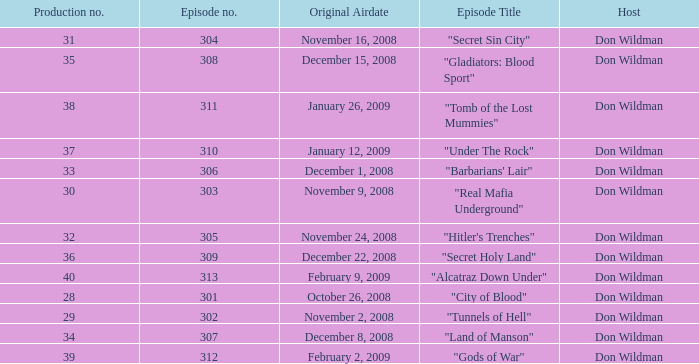What is the episode number of the episode that originally aired on January 26, 2009 and had a production number smaller than 38? 0.0. Would you be able to parse every entry in this table? {'header': ['Production no.', 'Episode no.', 'Original Airdate', 'Episode Title', 'Host'], 'rows': [['31', '304', 'November 16, 2008', '"Secret Sin City"', 'Don Wildman'], ['35', '308', 'December 15, 2008', '"Gladiators: Blood Sport"', 'Don Wildman'], ['38', '311', 'January 26, 2009', '"Tomb of the Lost Mummies"', 'Don Wildman'], ['37', '310', 'January 12, 2009', '"Under The Rock"', 'Don Wildman'], ['33', '306', 'December 1, 2008', '"Barbarians\' Lair"', 'Don Wildman'], ['30', '303', 'November 9, 2008', '"Real Mafia Underground"', 'Don Wildman'], ['32', '305', 'November 24, 2008', '"Hitler\'s Trenches"', 'Don Wildman'], ['36', '309', 'December 22, 2008', '"Secret Holy Land"', 'Don Wildman'], ['40', '313', 'February 9, 2009', '"Alcatraz Down Under"', 'Don Wildman'], ['28', '301', 'October 26, 2008', '"City of Blood"', 'Don Wildman'], ['29', '302', 'November 2, 2008', '"Tunnels of Hell"', 'Don Wildman'], ['34', '307', 'December 8, 2008', '"Land of Manson"', 'Don Wildman'], ['39', '312', 'February 2, 2009', '"Gods of War"', 'Don Wildman']]} 